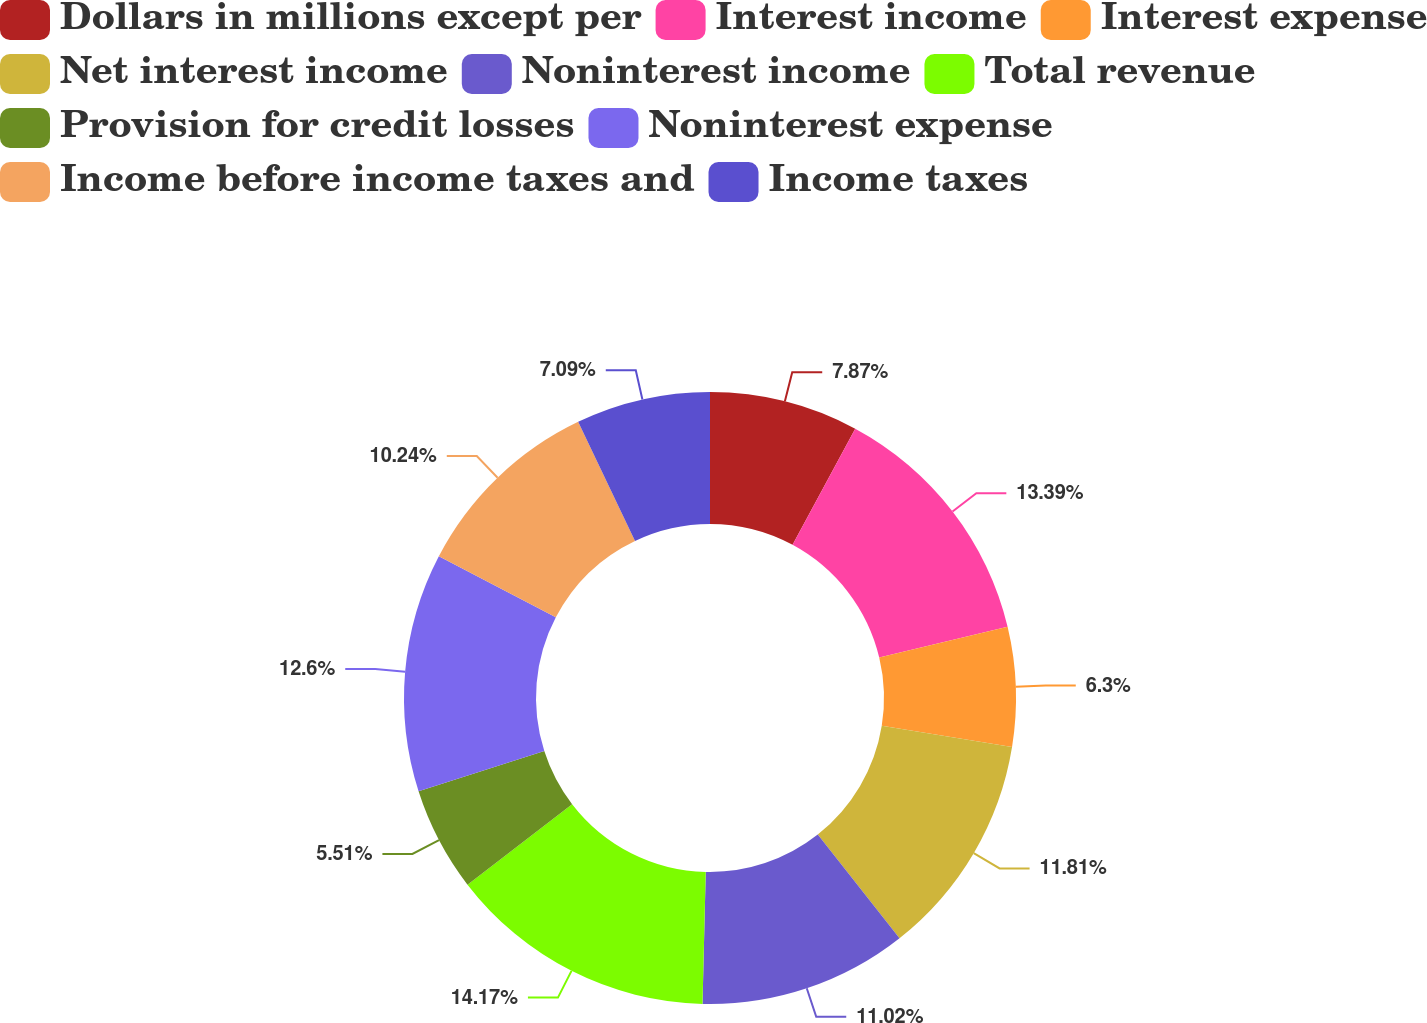Convert chart. <chart><loc_0><loc_0><loc_500><loc_500><pie_chart><fcel>Dollars in millions except per<fcel>Interest income<fcel>Interest expense<fcel>Net interest income<fcel>Noninterest income<fcel>Total revenue<fcel>Provision for credit losses<fcel>Noninterest expense<fcel>Income before income taxes and<fcel>Income taxes<nl><fcel>7.87%<fcel>13.39%<fcel>6.3%<fcel>11.81%<fcel>11.02%<fcel>14.17%<fcel>5.51%<fcel>12.6%<fcel>10.24%<fcel>7.09%<nl></chart> 